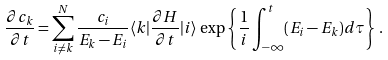Convert formula to latex. <formula><loc_0><loc_0><loc_500><loc_500>\frac { \partial c _ { k } } { \partial t } = \sum _ { i \neq k } ^ { N } \frac { c _ { i } } { E _ { k } - E _ { i } } \langle k | \frac { \partial H } { \partial t } | i \rangle \, \exp \left \{ \frac { 1 } { i } \int _ { - \infty } ^ { t } ( E _ { i } - E _ { k } ) d \tau \right \} \, .</formula> 